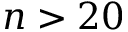<formula> <loc_0><loc_0><loc_500><loc_500>n > 2 0</formula> 